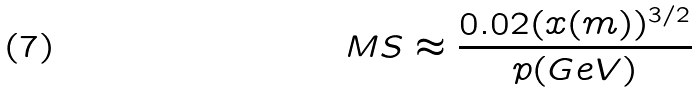<formula> <loc_0><loc_0><loc_500><loc_500>M S \approx \frac { 0 . 0 2 ( x ( m ) ) ^ { 3 / 2 } } { p ( G e V ) }</formula> 